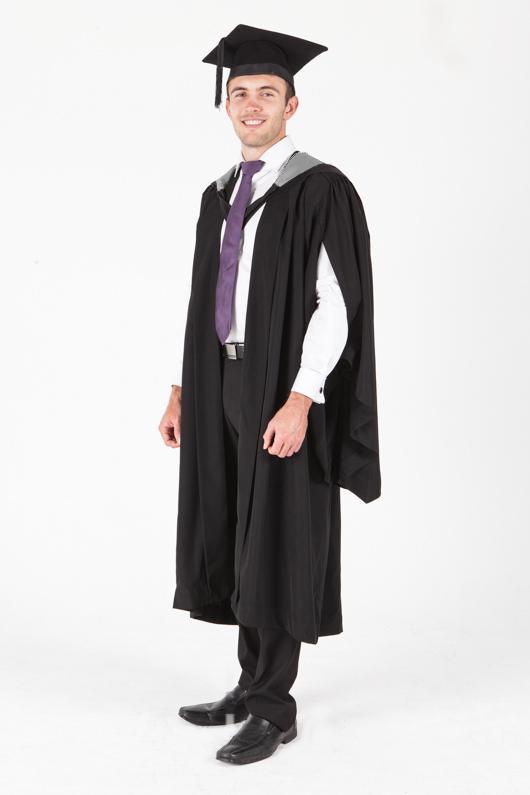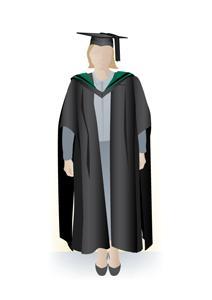The first image is the image on the left, the second image is the image on the right. Evaluate the accuracy of this statement regarding the images: "There are two people in graduation-type robes in the left image.". Is it true? Answer yes or no. No. 